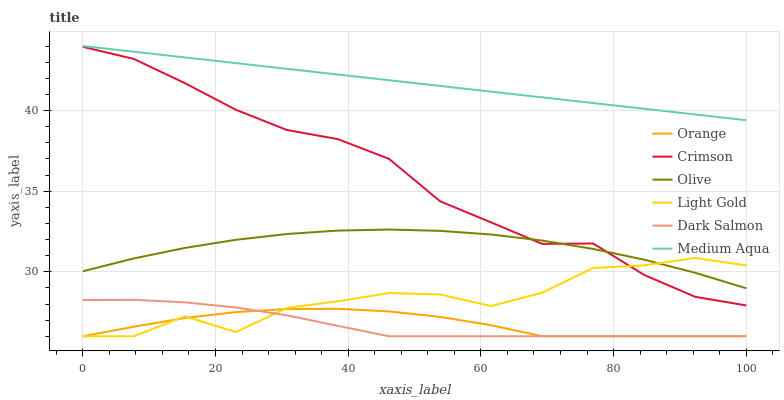Does Dark Salmon have the minimum area under the curve?
Answer yes or no. Yes. Does Medium Aqua have the maximum area under the curve?
Answer yes or no. Yes. Does Crimson have the minimum area under the curve?
Answer yes or no. No. Does Crimson have the maximum area under the curve?
Answer yes or no. No. Is Medium Aqua the smoothest?
Answer yes or no. Yes. Is Light Gold the roughest?
Answer yes or no. Yes. Is Dark Salmon the smoothest?
Answer yes or no. No. Is Dark Salmon the roughest?
Answer yes or no. No. Does Dark Salmon have the lowest value?
Answer yes or no. Yes. Does Crimson have the lowest value?
Answer yes or no. No. Does Medium Aqua have the highest value?
Answer yes or no. Yes. Does Dark Salmon have the highest value?
Answer yes or no. No. Is Crimson less than Medium Aqua?
Answer yes or no. Yes. Is Medium Aqua greater than Olive?
Answer yes or no. Yes. Does Crimson intersect Light Gold?
Answer yes or no. Yes. Is Crimson less than Light Gold?
Answer yes or no. No. Is Crimson greater than Light Gold?
Answer yes or no. No. Does Crimson intersect Medium Aqua?
Answer yes or no. No. 